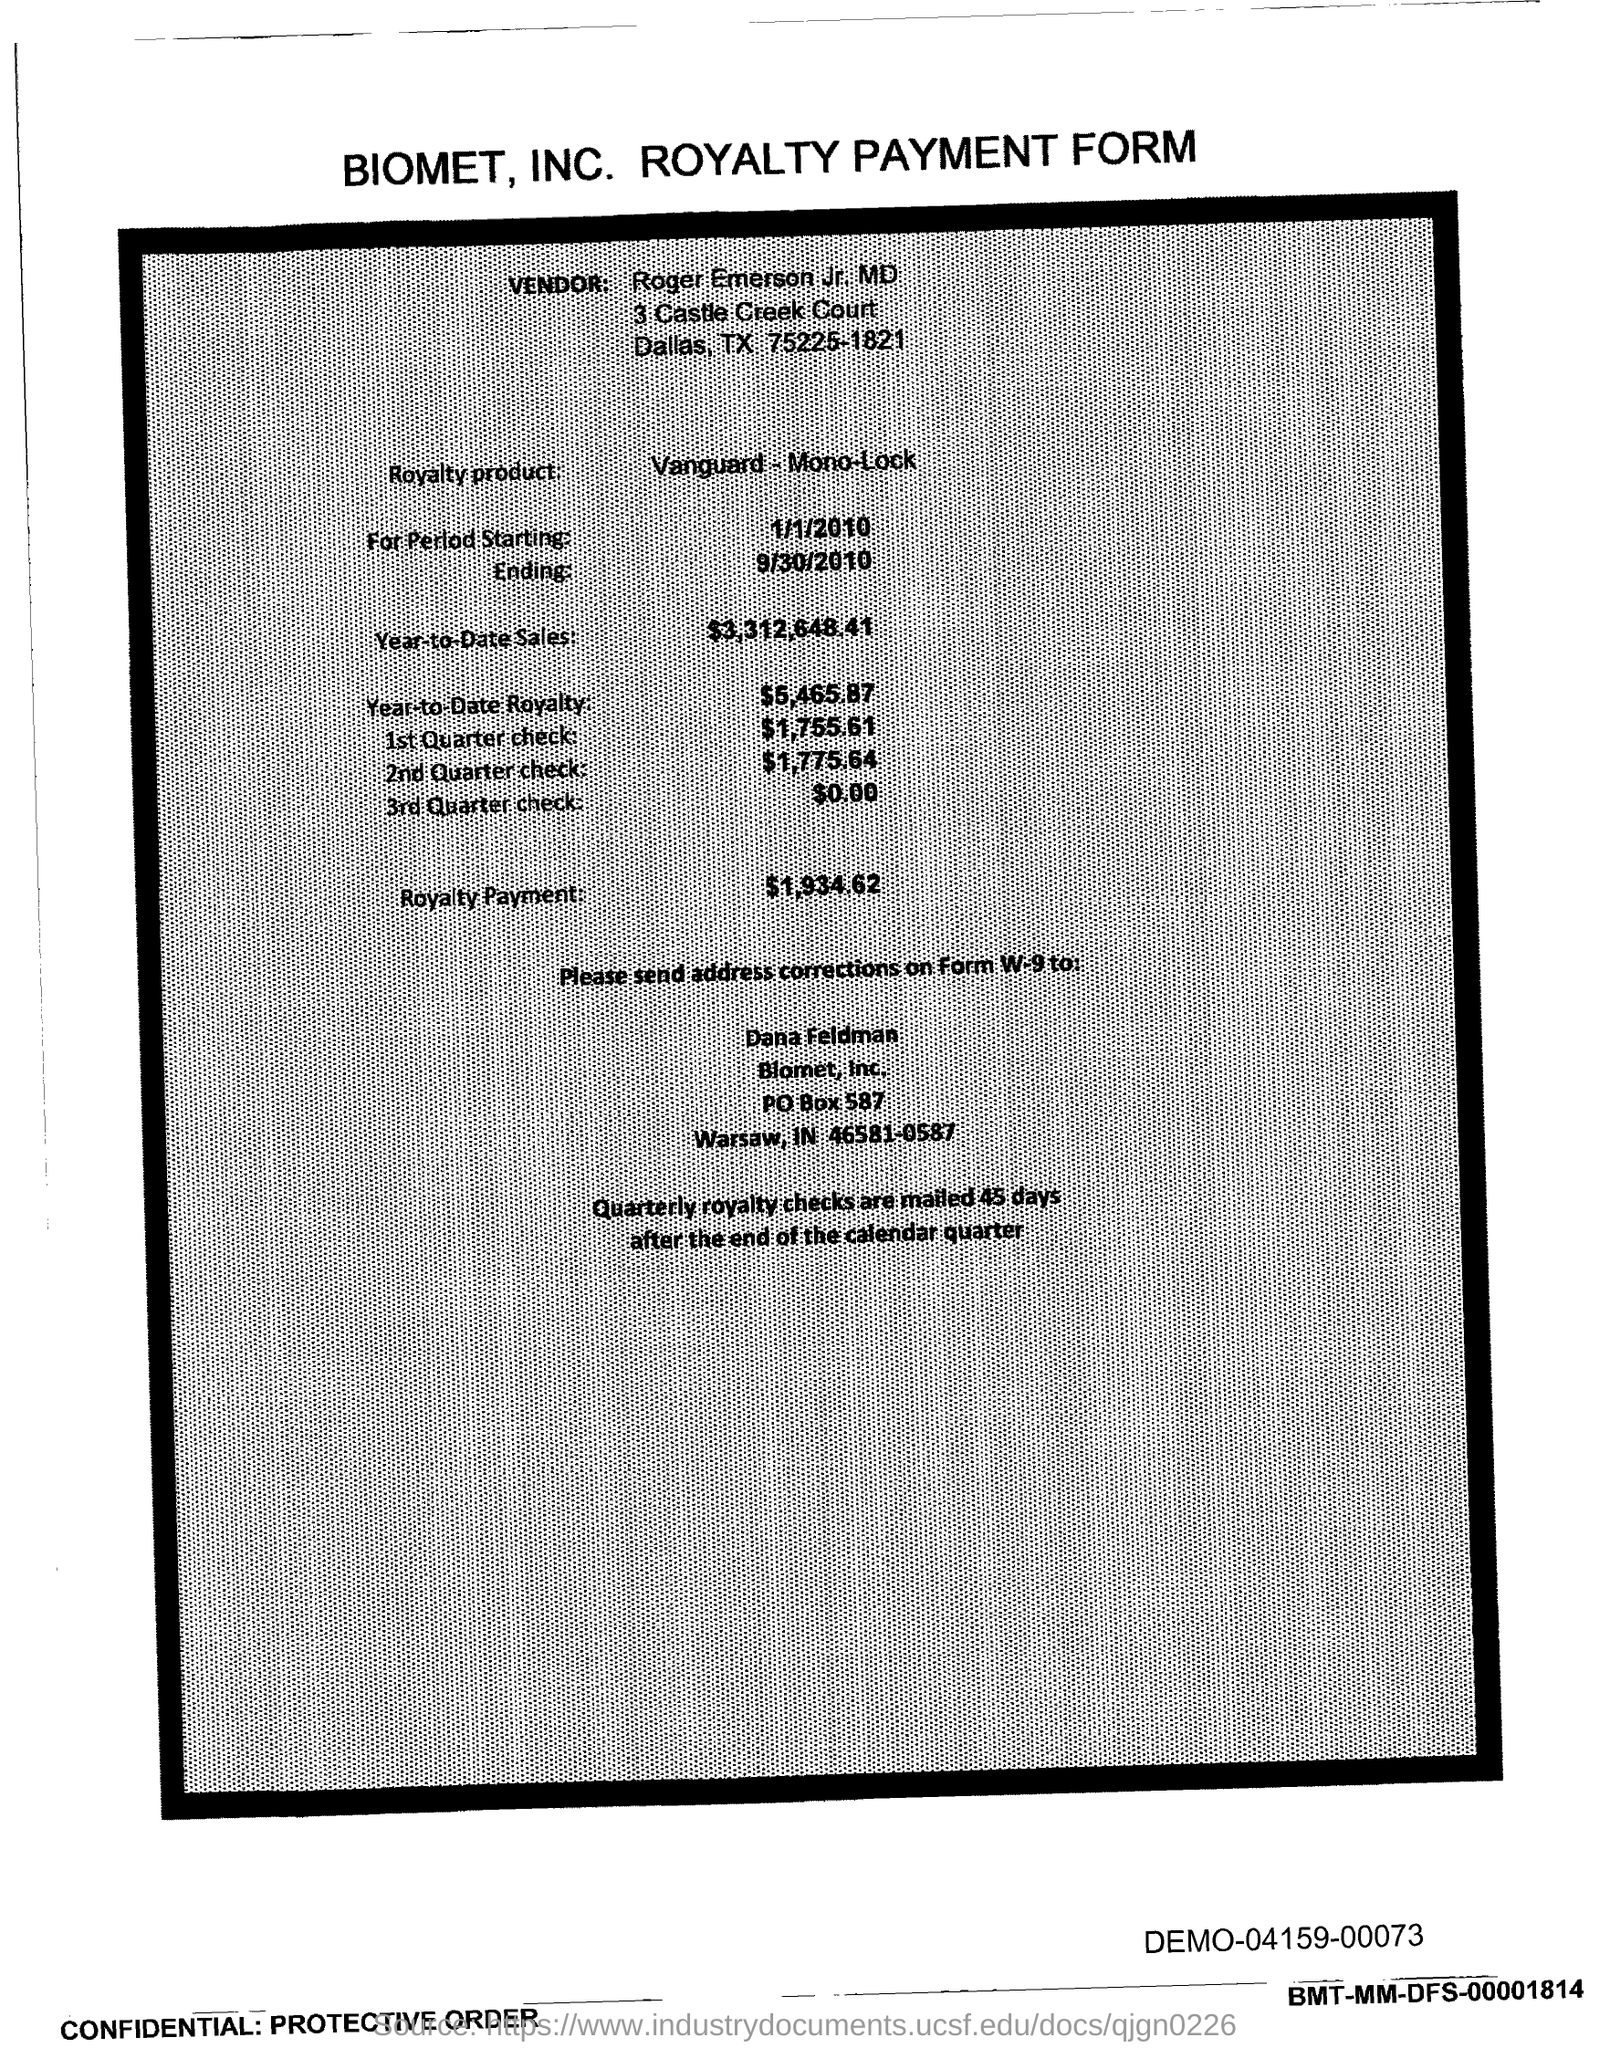Which company's royalty payment form is this?
Provide a succinct answer. BIOMET, INC. When are the quartely royalty checks mailed?
Offer a very short reply. 45 days after the end of the calendar quarter. Who is the vendor mentioned in the form?
Provide a succinct answer. Roger Emerson Jr. MD. What is the royalty product given in the form?
Offer a very short reply. Vanguard - Mono-Lock. What is the Year-to-Date Sales of the royalty product?
Your response must be concise. $3,312,648.41. What is the Year-to-Date royalty of the product?
Give a very brief answer. $5,465.87. What is the royalty payment of the product mentioned in the form?
Your answer should be very brief. 1,934.62. What is the amount of 3rd Quarter check given in the form?
Offer a terse response. $0.00. What is the amount of 2nd Quarter check mentioned in the form?
Provide a succinct answer. 1,775.64. What is the amount of 1st quarter check mentioned in the form?
Ensure brevity in your answer.  $1,755.61. 